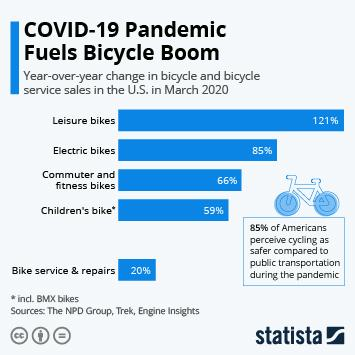Specify some key components in this picture. According to data from March 2020 in the United States, the growth rate of children's bicycles was less than 60% compared to the previous year, indicating a decrease in demand for this type of bicycle. In March 2020, the sales of commuter and fitness bikes in the U.S. increased by 66% compared to the same period the previous year. According to data collected in March 2020, the leisure bike type has shown a growth rate of more than 100% compared to the previous year in the United States. The year-over-year change in the sales of electric bikes in the U.S. in March 2020 was 85%. 